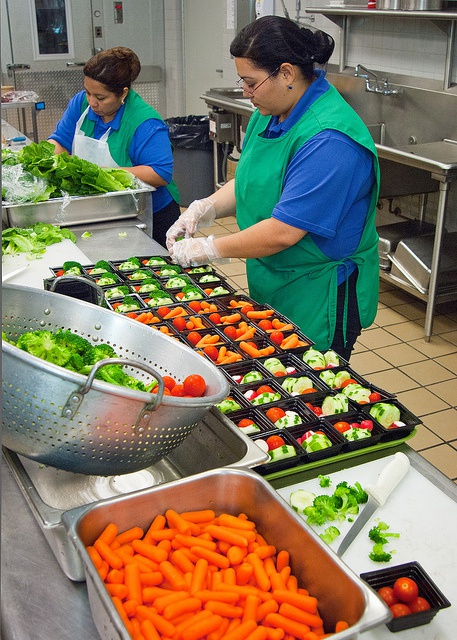Describe the objects in this image and their specific colors. I can see people in darkgray, teal, black, and blue tones, bowl in darkgray, lightgray, gray, and black tones, carrot in darkgray, red, orange, and maroon tones, people in darkgray, black, blue, and teal tones, and carrot in darkgray, red, orange, and black tones in this image. 